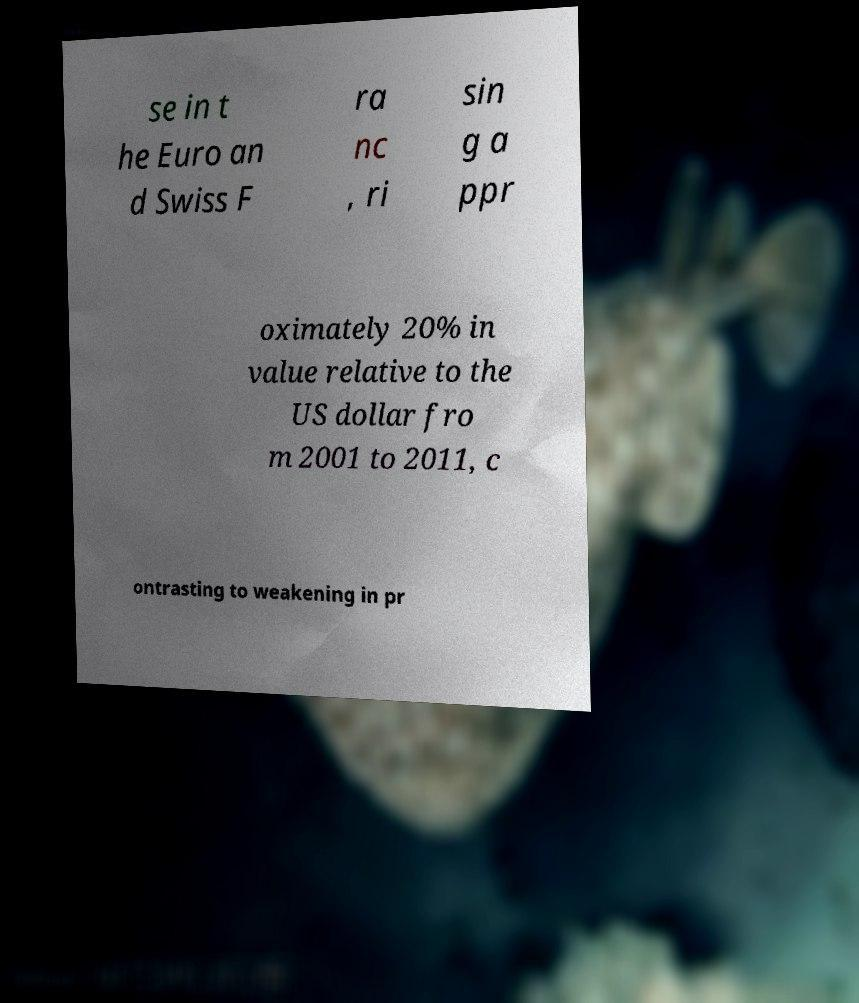Could you assist in decoding the text presented in this image and type it out clearly? se in t he Euro an d Swiss F ra nc , ri sin g a ppr oximately 20% in value relative to the US dollar fro m 2001 to 2011, c ontrasting to weakening in pr 